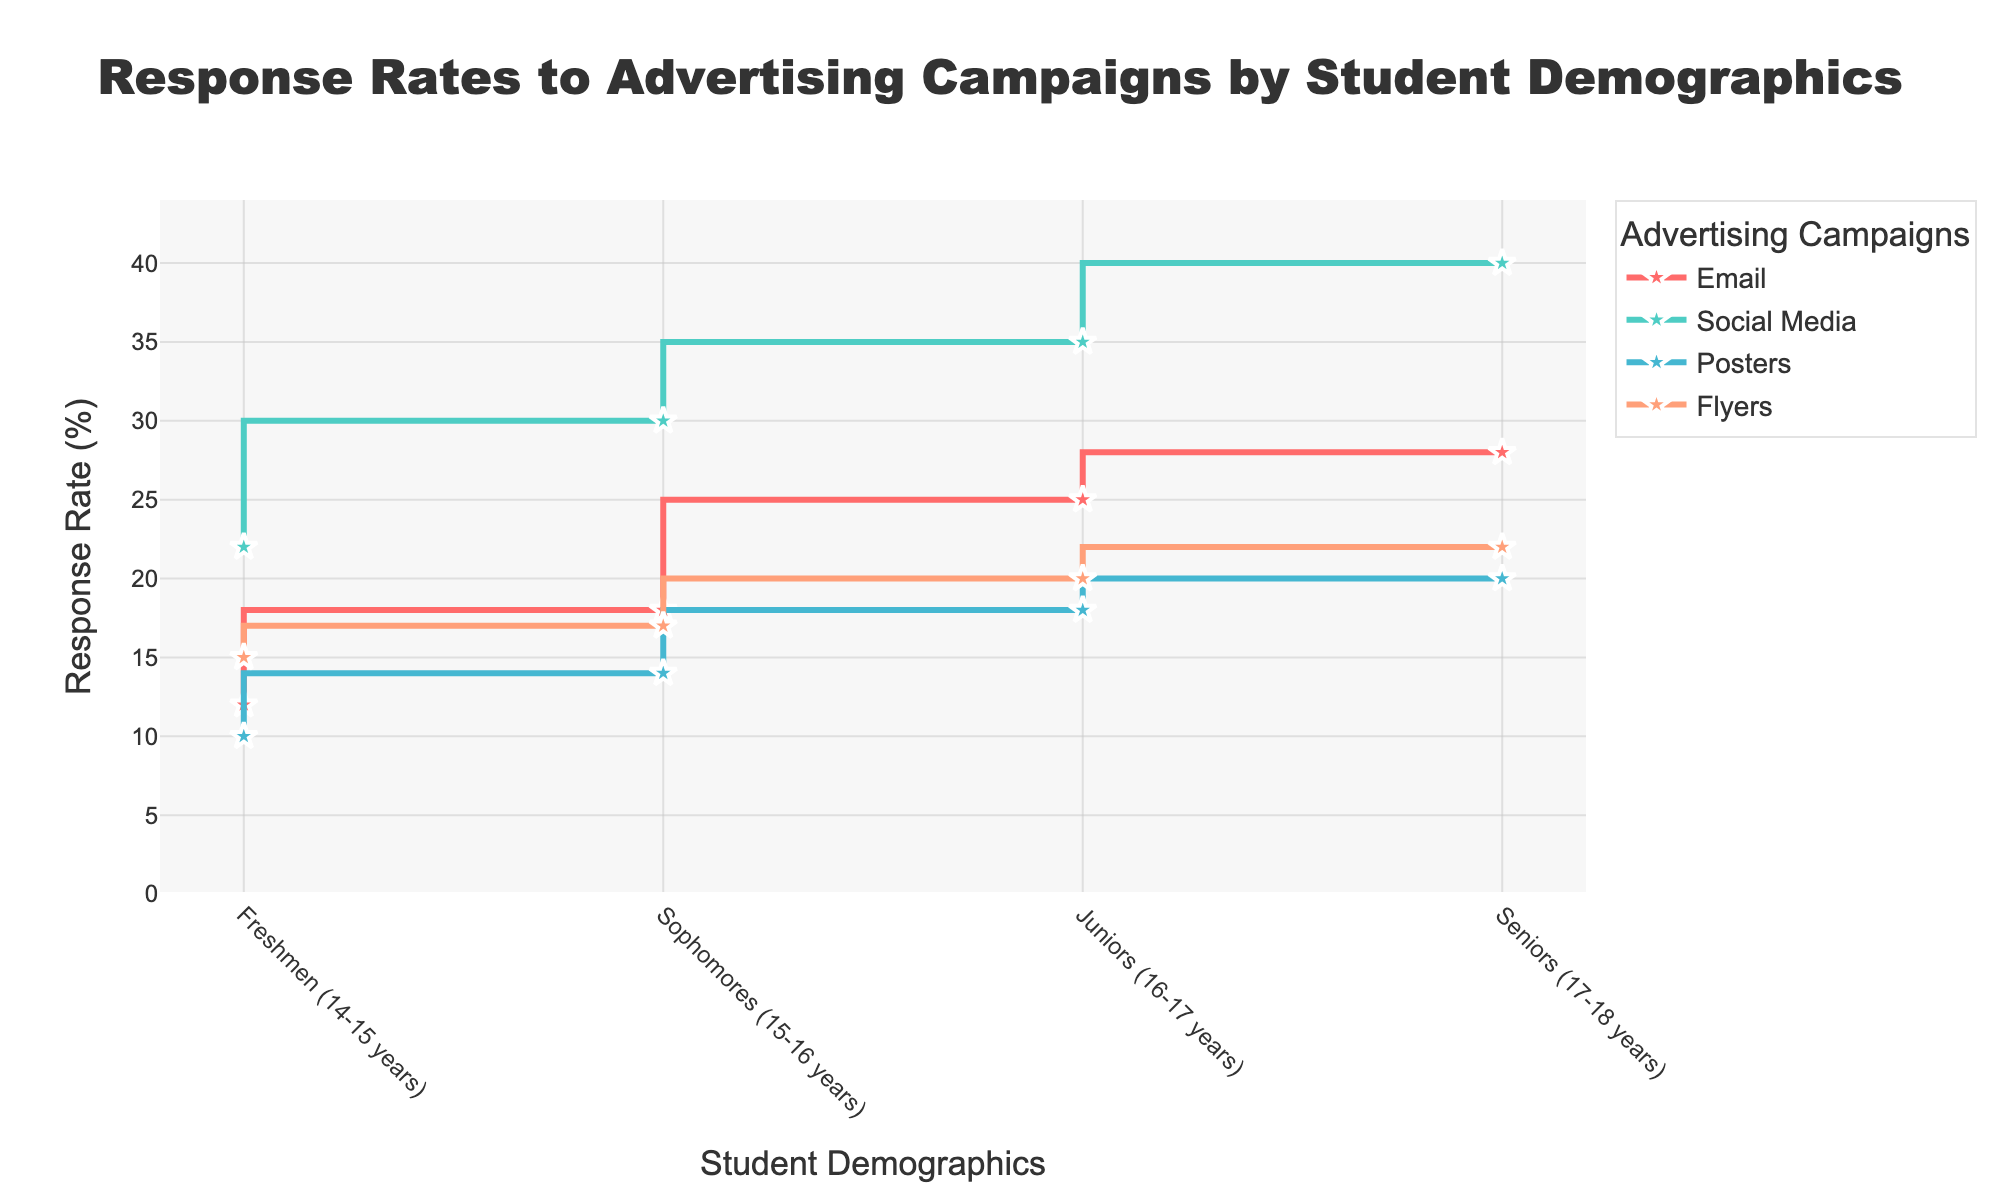What is the title of the plot? The title is the text displayed at the top of the plot. It summarizes the content or main theme of the plot.
Answer: Response Rates to Advertising Campaigns by Student Demographics Which advertising campaign had the highest response rate for Seniors (17-18 years)? To answer this, locate the data point for Seniors and find the highest value among the advertising campaigns. The Social Media campaign has a response rate of 40%, which is the highest.
Answer: Social Media What is the difference in response rate between Email and Flyers among Juniors (16-17 years)? First, find the response rates for Email and Flyers for the Juniors demographic (25% and 20% respectively). Then, calculate the difference: 25 - 20 = 5%
Answer: 5% Which student demographic had the lowest response rate for Posters? Look at the vertical positions of the data points for Posters for each demographic. Freshmen (14-15 years) have the lowest response rate of 10%.
Answer: Freshmen (14-15 years) On average, which advertising campaign has the highest response rate across all demographics? Calculate the average response rate for each campaign: 
Emails: (12 + 18 + 25 + 28) / 4 = 20.75,
Social Media: (22 + 30 + 35 + 40) / 4 = 31.75,
Posters: (10 + 14 + 18 + 20) / 4 = 15.5,
Flyers: (15 + 17 + 20 + 22) / 4 = 18.5. 
The Social Media campaign has the highest average response rate.
Answer: Social Media How do the response rates for Flyers among Sophomores (15-16 years) and Freshmen (14-15 years) compare? Compare the Flyers response rate for both demographics: Sophomores (17%) and Freshmen (15%). The Flyers campaign had a higher response rate among Sophomores than Freshmen.
Answer: Sophomores (15-16 years) have a higher response rate What is the increase in response rate for Email from Freshmen (14-15 years) to Seniors (17-18 years)? Find the response rates for Email for Freshmen (12%) and Seniors (28%). Then, calculate the increase: 28 - 12 = 16%
Answer: 16% Which advertising campaign had a consistent increase in response rate across all demographics? By examining the trends for each campaign, Social Media shows a consistent increase from Freshmen to Seniors: 22%, 30%, 35%, and 40%.
Answer: Social Media What is the total response rate for Posters across all demographics? Sum the response rates for Posters for each demographic: 10 + 14 + 18 + 20 = 62%
Answer: 62% 